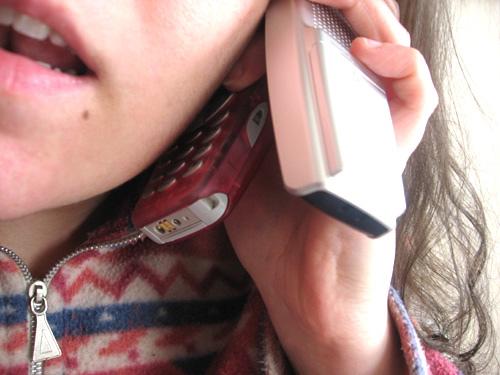How many devices is the woman holding?
Concise answer only. 2. Is this an older woman?
Give a very brief answer. No. Is this a cordless phone or cord phone?
Quick response, please. Cordless. 